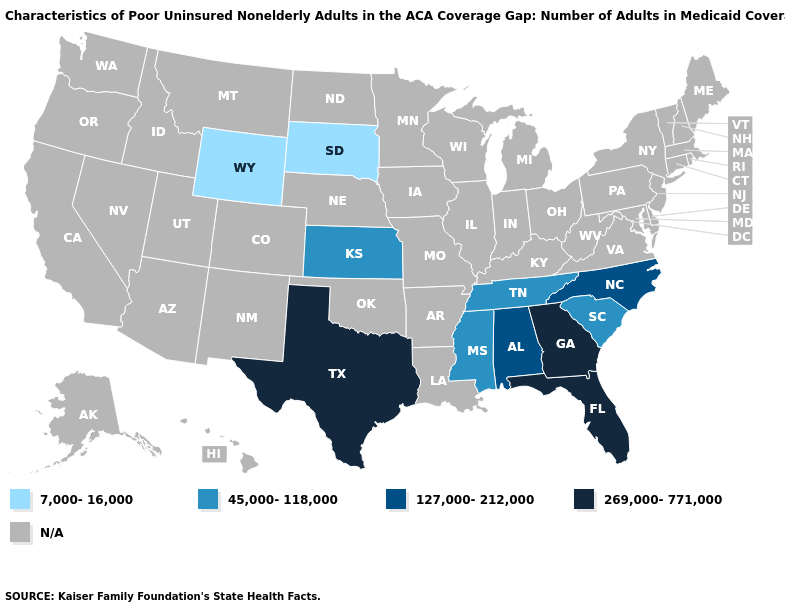Does Tennessee have the lowest value in the South?
Write a very short answer. Yes. What is the value of Montana?
Concise answer only. N/A. Which states have the lowest value in the West?
Be succinct. Wyoming. What is the value of Oklahoma?
Short answer required. N/A. Name the states that have a value in the range 127,000-212,000?
Give a very brief answer. Alabama, North Carolina. Does South Carolina have the lowest value in the South?
Quick response, please. Yes. What is the highest value in the USA?
Concise answer only. 269,000-771,000. What is the value of Rhode Island?
Quick response, please. N/A. Which states hav the highest value in the MidWest?
Give a very brief answer. Kansas. What is the value of Delaware?
Keep it brief. N/A. Name the states that have a value in the range 127,000-212,000?
Write a very short answer. Alabama, North Carolina. What is the value of Nebraska?
Concise answer only. N/A. What is the value of Idaho?
Give a very brief answer. N/A. 